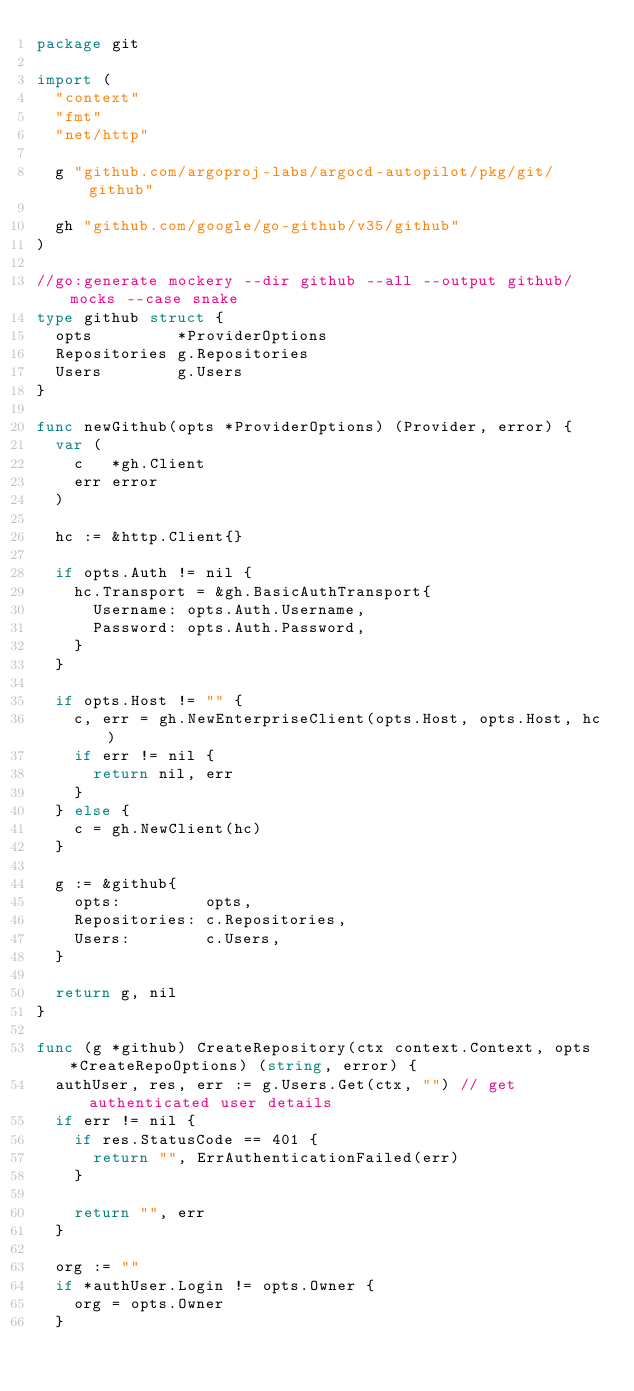<code> <loc_0><loc_0><loc_500><loc_500><_Go_>package git

import (
	"context"
	"fmt"
	"net/http"

	g "github.com/argoproj-labs/argocd-autopilot/pkg/git/github"

	gh "github.com/google/go-github/v35/github"
)

//go:generate mockery --dir github --all --output github/mocks --case snake
type github struct {
	opts         *ProviderOptions
	Repositories g.Repositories
	Users        g.Users
}

func newGithub(opts *ProviderOptions) (Provider, error) {
	var (
		c   *gh.Client
		err error
	)

	hc := &http.Client{}

	if opts.Auth != nil {
		hc.Transport = &gh.BasicAuthTransport{
			Username: opts.Auth.Username,
			Password: opts.Auth.Password,
		}
	}

	if opts.Host != "" {
		c, err = gh.NewEnterpriseClient(opts.Host, opts.Host, hc)
		if err != nil {
			return nil, err
		}
	} else {
		c = gh.NewClient(hc)
	}

	g := &github{
		opts:         opts,
		Repositories: c.Repositories,
		Users:        c.Users,
	}

	return g, nil
}

func (g *github) CreateRepository(ctx context.Context, opts *CreateRepoOptions) (string, error) {
	authUser, res, err := g.Users.Get(ctx, "") // get authenticated user details
	if err != nil {
		if res.StatusCode == 401 {
			return "", ErrAuthenticationFailed(err)
		}

		return "", err
	}

	org := ""
	if *authUser.Login != opts.Owner {
		org = opts.Owner
	}
</code> 